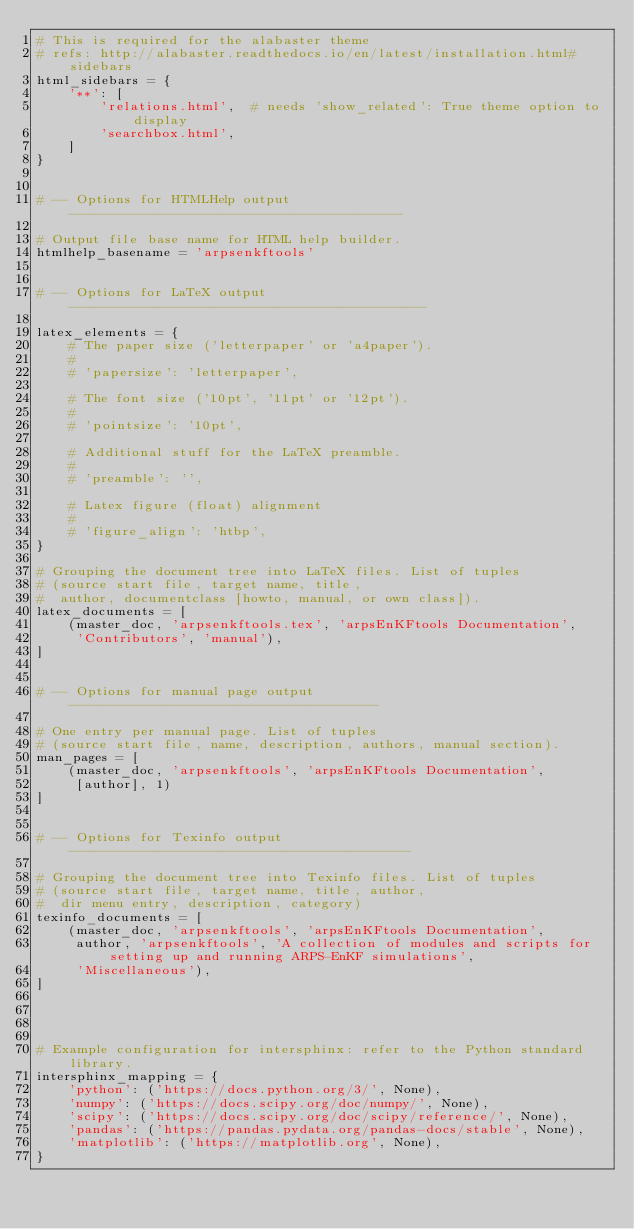Convert code to text. <code><loc_0><loc_0><loc_500><loc_500><_Python_># This is required for the alabaster theme
# refs: http://alabaster.readthedocs.io/en/latest/installation.html#sidebars
html_sidebars = {
    '**': [
        'relations.html',  # needs 'show_related': True theme option to display
        'searchbox.html',
    ]
}


# -- Options for HTMLHelp output ------------------------------------------

# Output file base name for HTML help builder.
htmlhelp_basename = 'arpsenkftools'


# -- Options for LaTeX output ---------------------------------------------

latex_elements = {
    # The paper size ('letterpaper' or 'a4paper').
    #
    # 'papersize': 'letterpaper',

    # The font size ('10pt', '11pt' or '12pt').
    #
    # 'pointsize': '10pt',

    # Additional stuff for the LaTeX preamble.
    #
    # 'preamble': '',

    # Latex figure (float) alignment
    #
    # 'figure_align': 'htbp',
}

# Grouping the document tree into LaTeX files. List of tuples
# (source start file, target name, title,
#  author, documentclass [howto, manual, or own class]).
latex_documents = [
    (master_doc, 'arpsenkftools.tex', 'arpsEnKFtools Documentation',
     'Contributors', 'manual'),
]


# -- Options for manual page output ---------------------------------------

# One entry per manual page. List of tuples
# (source start file, name, description, authors, manual section).
man_pages = [
    (master_doc, 'arpsenkftools', 'arpsEnKFtools Documentation',
     [author], 1)
]


# -- Options for Texinfo output -------------------------------------------

# Grouping the document tree into Texinfo files. List of tuples
# (source start file, target name, title, author,
#  dir menu entry, description, category)
texinfo_documents = [
    (master_doc, 'arpsenkftools', 'arpsEnKFtools Documentation',
     author, 'arpsenkftools', 'A collection of modules and scripts for setting up and running ARPS-EnKF simulations',
     'Miscellaneous'),
]




# Example configuration for intersphinx: refer to the Python standard library.
intersphinx_mapping = {
    'python': ('https://docs.python.org/3/', None),
    'numpy': ('https://docs.scipy.org/doc/numpy/', None),
    'scipy': ('https://docs.scipy.org/doc/scipy/reference/', None),
    'pandas': ('https://pandas.pydata.org/pandas-docs/stable', None),
    'matplotlib': ('https://matplotlib.org', None),
}
</code> 